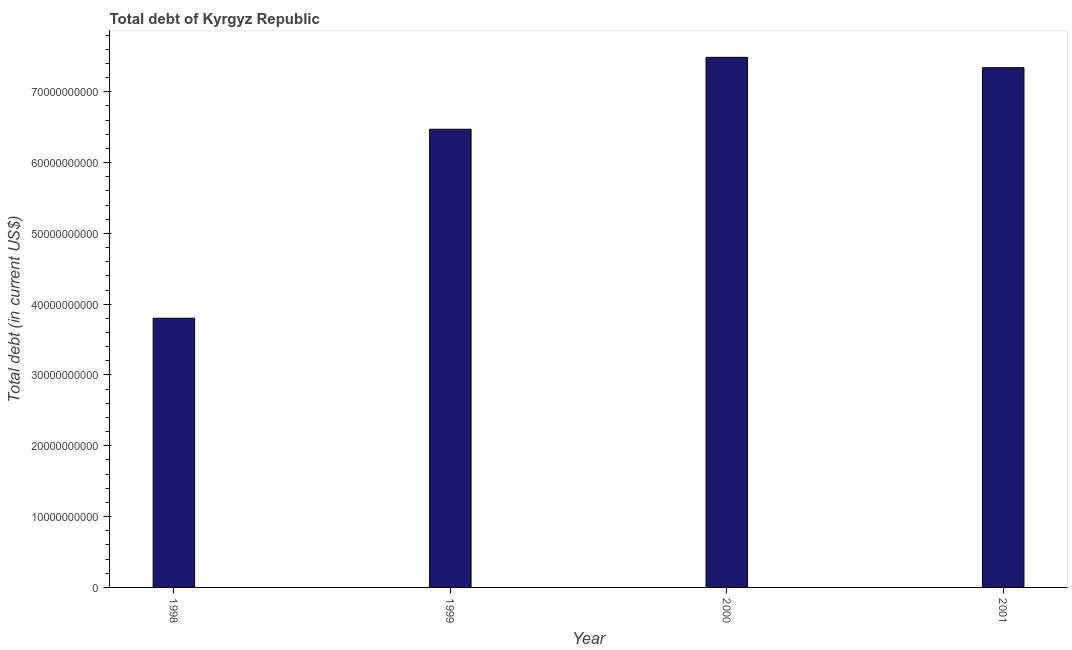Does the graph contain grids?
Ensure brevity in your answer.  No. What is the title of the graph?
Your answer should be very brief. Total debt of Kyrgyz Republic. What is the label or title of the X-axis?
Provide a succinct answer. Year. What is the label or title of the Y-axis?
Offer a very short reply. Total debt (in current US$). What is the total debt in 1998?
Keep it short and to the point. 3.80e+1. Across all years, what is the maximum total debt?
Provide a succinct answer. 7.49e+1. Across all years, what is the minimum total debt?
Your response must be concise. 3.80e+1. In which year was the total debt minimum?
Your answer should be compact. 1998. What is the sum of the total debt?
Give a very brief answer. 2.51e+11. What is the difference between the total debt in 1998 and 1999?
Your response must be concise. -2.67e+1. What is the average total debt per year?
Your answer should be compact. 6.27e+1. What is the median total debt?
Offer a very short reply. 6.90e+1. Do a majority of the years between 1999 and 1998 (inclusive) have total debt greater than 32000000000 US$?
Offer a very short reply. No. What is the ratio of the total debt in 1998 to that in 1999?
Provide a short and direct response. 0.59. What is the difference between the highest and the second highest total debt?
Your answer should be compact. 1.47e+09. Is the sum of the total debt in 1998 and 2000 greater than the maximum total debt across all years?
Provide a succinct answer. Yes. What is the difference between the highest and the lowest total debt?
Ensure brevity in your answer.  3.68e+1. In how many years, is the total debt greater than the average total debt taken over all years?
Offer a terse response. 3. How many bars are there?
Give a very brief answer. 4. What is the difference between two consecutive major ticks on the Y-axis?
Provide a succinct answer. 1.00e+1. What is the Total debt (in current US$) of 1998?
Make the answer very short. 3.80e+1. What is the Total debt (in current US$) of 1999?
Your response must be concise. 6.47e+1. What is the Total debt (in current US$) in 2000?
Your answer should be compact. 7.49e+1. What is the Total debt (in current US$) of 2001?
Provide a short and direct response. 7.34e+1. What is the difference between the Total debt (in current US$) in 1998 and 1999?
Make the answer very short. -2.67e+1. What is the difference between the Total debt (in current US$) in 1998 and 2000?
Provide a short and direct response. -3.68e+1. What is the difference between the Total debt (in current US$) in 1998 and 2001?
Your answer should be compact. -3.54e+1. What is the difference between the Total debt (in current US$) in 1999 and 2000?
Your answer should be very brief. -1.02e+1. What is the difference between the Total debt (in current US$) in 1999 and 2001?
Ensure brevity in your answer.  -8.69e+09. What is the difference between the Total debt (in current US$) in 2000 and 2001?
Keep it short and to the point. 1.47e+09. What is the ratio of the Total debt (in current US$) in 1998 to that in 1999?
Make the answer very short. 0.59. What is the ratio of the Total debt (in current US$) in 1998 to that in 2000?
Ensure brevity in your answer.  0.51. What is the ratio of the Total debt (in current US$) in 1998 to that in 2001?
Your answer should be very brief. 0.52. What is the ratio of the Total debt (in current US$) in 1999 to that in 2000?
Your response must be concise. 0.86. What is the ratio of the Total debt (in current US$) in 1999 to that in 2001?
Your answer should be very brief. 0.88. What is the ratio of the Total debt (in current US$) in 2000 to that in 2001?
Keep it short and to the point. 1.02. 